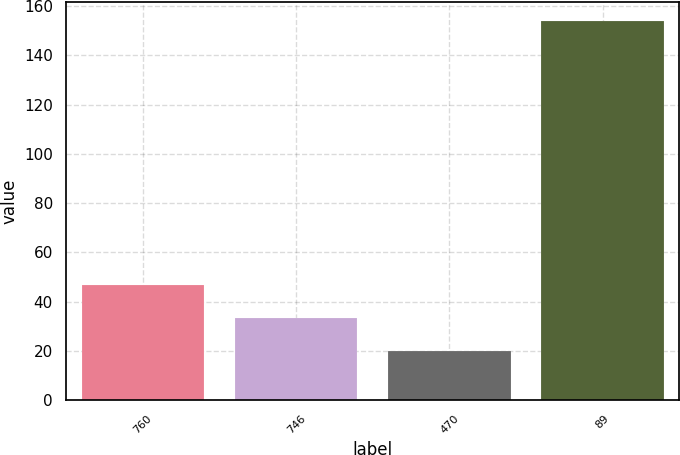Convert chart to OTSL. <chart><loc_0><loc_0><loc_500><loc_500><bar_chart><fcel>760<fcel>746<fcel>470<fcel>89<nl><fcel>46.8<fcel>33.4<fcel>20<fcel>154<nl></chart> 